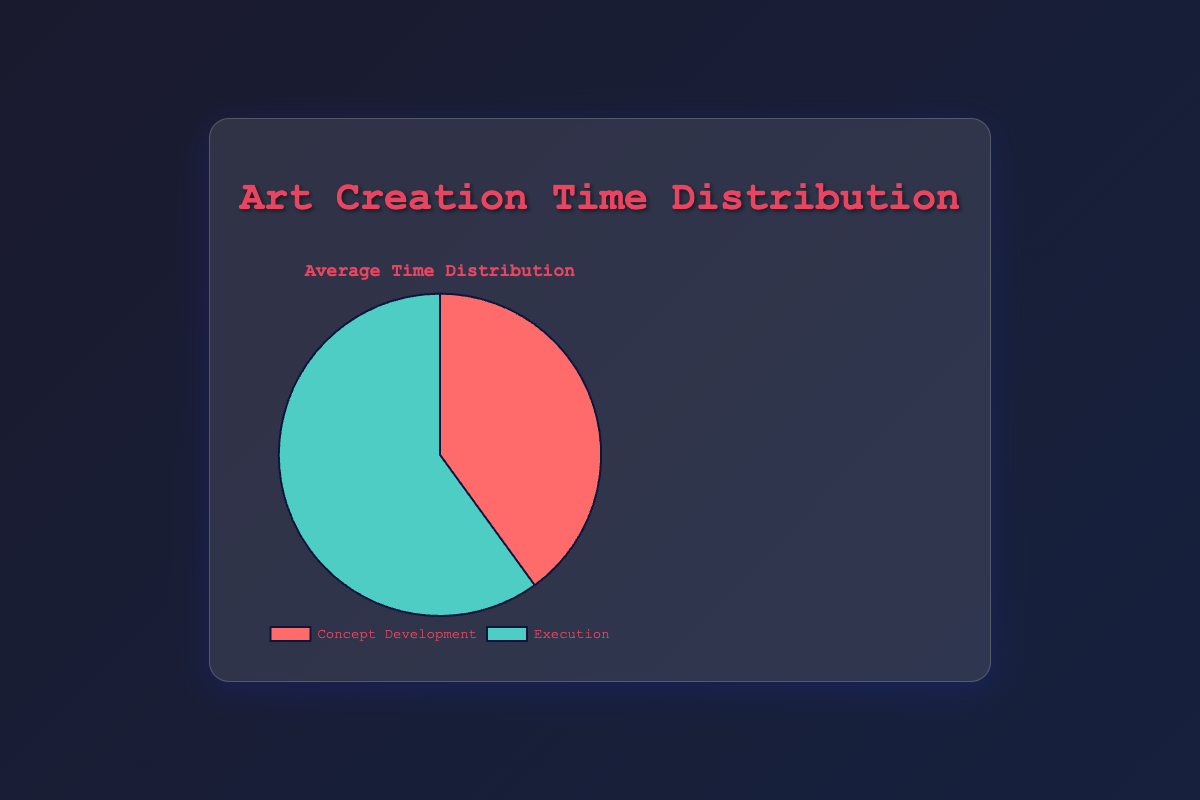What's the average percentage of time spent on concept development across all art pieces? To find the average percentage of time spent on concept development, sum the values for concept development across all art pieces (35 + 45 + 30 + 50 + 40) and divide by the number of art pieces (5). The calculation is: (35 + 45 + 30 + 50 + 40) / 5 = 200 / 5 = 40.
Answer: 40 Which art piece requires the highest percentage of time spent on execution? Compare the execution percentages of all art pieces: Celestial Dreams (65%), Urban Jungle (55%), Ocean Whispers (70%), Mechanical Heart (50%), Ethereal Forest (60%). The highest value is 70% for Ocean Whispers.
Answer: Ocean Whispers By how much does the execution time percentage exceed the concept development percentage for Urban Jungle? Urban Jungle's execution percentage is 55% and its concept development percentage is 45%. The difference is 55% - 45% = 10%.
Answer: 10% What is the difference between the highest and lowest percentage of time spent on execution? The highest percentage of time spent on execution is for Ocean Whispers (70%) and the lowest is for Mechanical Heart (50%). The difference is 70% - 50% = 20%.
Answer: 20% How many art pieces have a higher percentage of time spent on concept development than on execution? Compare percentages of concept development and execution for each art piece. Celestial Dreams: 35 < 65, Urban Jungle: 45 < 55, Ocean Whispers: 30 < 70, Mechanical Heart: 50 = 50, Ethereal Forest: 40 < 60. None of the art pieces have a higher percentage of time spent on concept development than on execution.
Answer: 0 For the art piece titled "Mechanical Heart," what is the composite value of the differences between concept development and execution? For Mechanical Heart, both concept development and execution are 50%. The differences are 50 - 50 (first difference), and 50 - 50 (second difference). Composite value = 0 + 0 = 0.
Answer: 0 